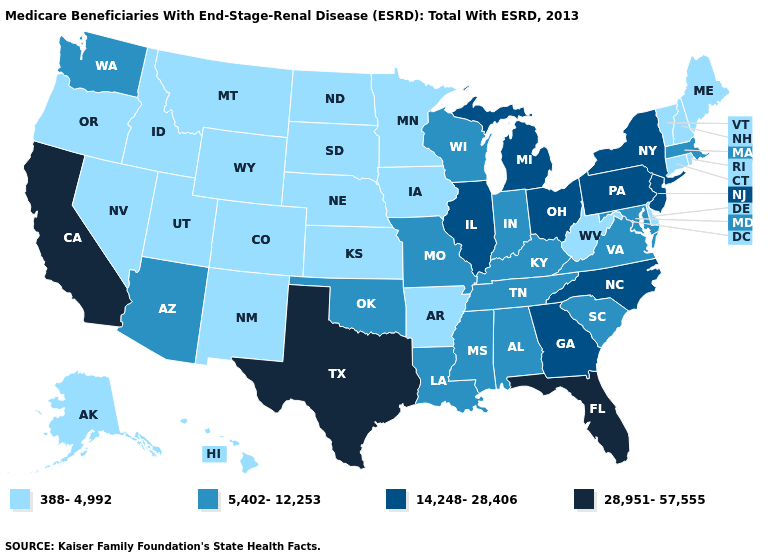Which states have the highest value in the USA?
Keep it brief. California, Florida, Texas. What is the highest value in the USA?
Quick response, please. 28,951-57,555. Does California have the highest value in the USA?
Write a very short answer. Yes. Name the states that have a value in the range 28,951-57,555?
Short answer required. California, Florida, Texas. Name the states that have a value in the range 388-4,992?
Quick response, please. Alaska, Arkansas, Colorado, Connecticut, Delaware, Hawaii, Idaho, Iowa, Kansas, Maine, Minnesota, Montana, Nebraska, Nevada, New Hampshire, New Mexico, North Dakota, Oregon, Rhode Island, South Dakota, Utah, Vermont, West Virginia, Wyoming. Which states have the lowest value in the West?
Short answer required. Alaska, Colorado, Hawaii, Idaho, Montana, Nevada, New Mexico, Oregon, Utah, Wyoming. What is the value of Maryland?
Write a very short answer. 5,402-12,253. What is the value of New Mexico?
Keep it brief. 388-4,992. Does Rhode Island have the lowest value in the USA?
Give a very brief answer. Yes. Which states have the lowest value in the South?
Give a very brief answer. Arkansas, Delaware, West Virginia. Does California have the highest value in the USA?
Be succinct. Yes. What is the lowest value in the South?
Answer briefly. 388-4,992. Does California have the highest value in the West?
Answer briefly. Yes. Among the states that border Rhode Island , which have the highest value?
Answer briefly. Massachusetts. Which states have the lowest value in the West?
Answer briefly. Alaska, Colorado, Hawaii, Idaho, Montana, Nevada, New Mexico, Oregon, Utah, Wyoming. 